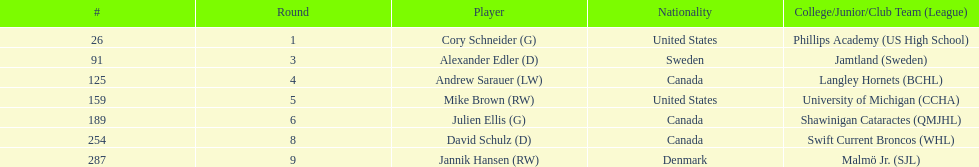Which players are not from denmark? Cory Schneider (G), Alexander Edler (D), Andrew Sarauer (LW), Mike Brown (RW), Julien Ellis (G), David Schulz (D). 